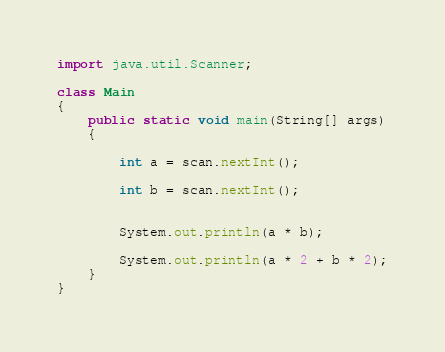<code> <loc_0><loc_0><loc_500><loc_500><_Java_>import java.util.Scanner;

class Main
{
    public static void main(String[] args)
    {
               
        int a = scan.nextInt();

        int b = scan.nextInt();
        

        System.out.println(a * b);

        System.out.println(a * 2 + b * 2);
    }  
}

</code> 